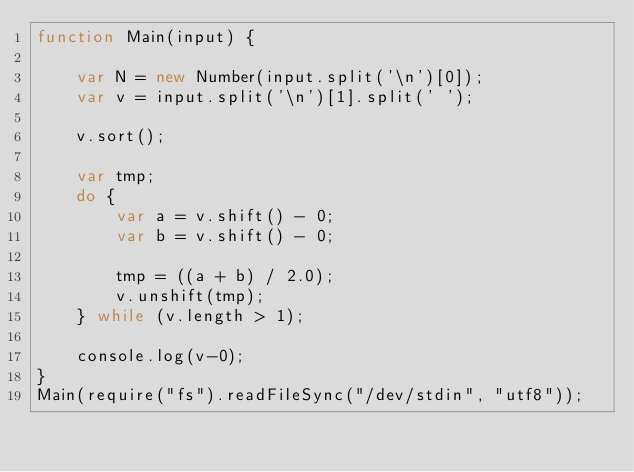<code> <loc_0><loc_0><loc_500><loc_500><_JavaScript_>function Main(input) {
 
    var N = new Number(input.split('\n')[0]);
    var v = input.split('\n')[1].split(' ');
 
    v.sort();

    var tmp;
    do {
        var a = v.shift() - 0;
        var b = v.shift() - 0;
        
        tmp = ((a + b) / 2.0);
        v.unshift(tmp);
    } while (v.length > 1);

    console.log(v-0);
}
Main(require("fs").readFileSync("/dev/stdin", "utf8"));</code> 